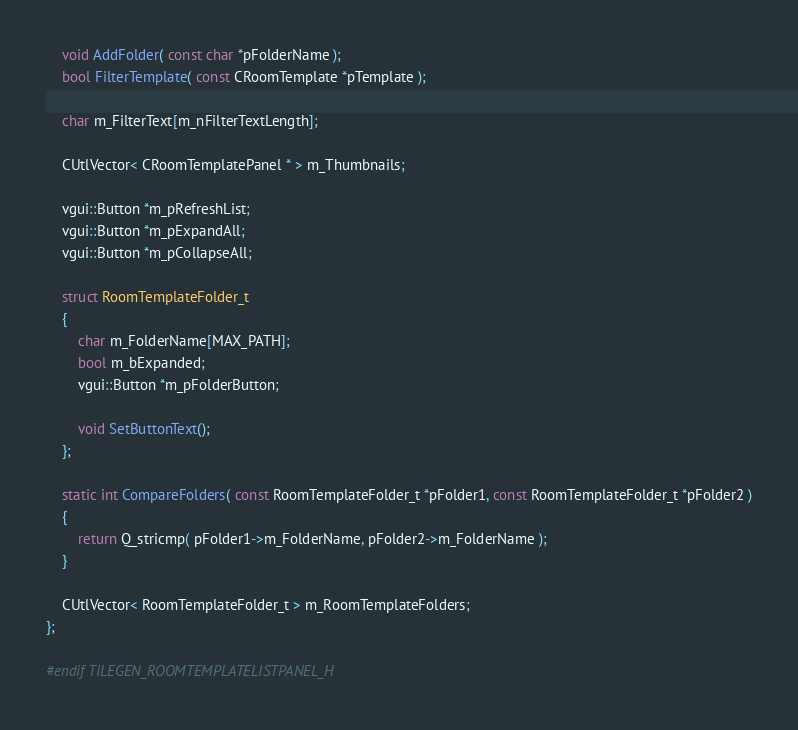<code> <loc_0><loc_0><loc_500><loc_500><_C_>	void AddFolder( const char *pFolderName );
	bool FilterTemplate( const CRoomTemplate *pTemplate );

	char m_FilterText[m_nFilterTextLength];

	CUtlVector< CRoomTemplatePanel * > m_Thumbnails;

	vgui::Button *m_pRefreshList;
	vgui::Button *m_pExpandAll;
	vgui::Button *m_pCollapseAll;
	
	struct RoomTemplateFolder_t
	{
		char m_FolderName[MAX_PATH];
		bool m_bExpanded;
		vgui::Button *m_pFolderButton;
		
		void SetButtonText();
	};

	static int CompareFolders( const RoomTemplateFolder_t *pFolder1, const RoomTemplateFolder_t *pFolder2 )
	{
		return Q_stricmp( pFolder1->m_FolderName, pFolder2->m_FolderName );
	}

	CUtlVector< RoomTemplateFolder_t > m_RoomTemplateFolders;
};

#endif TILEGEN_ROOMTEMPLATELISTPANEL_H</code> 